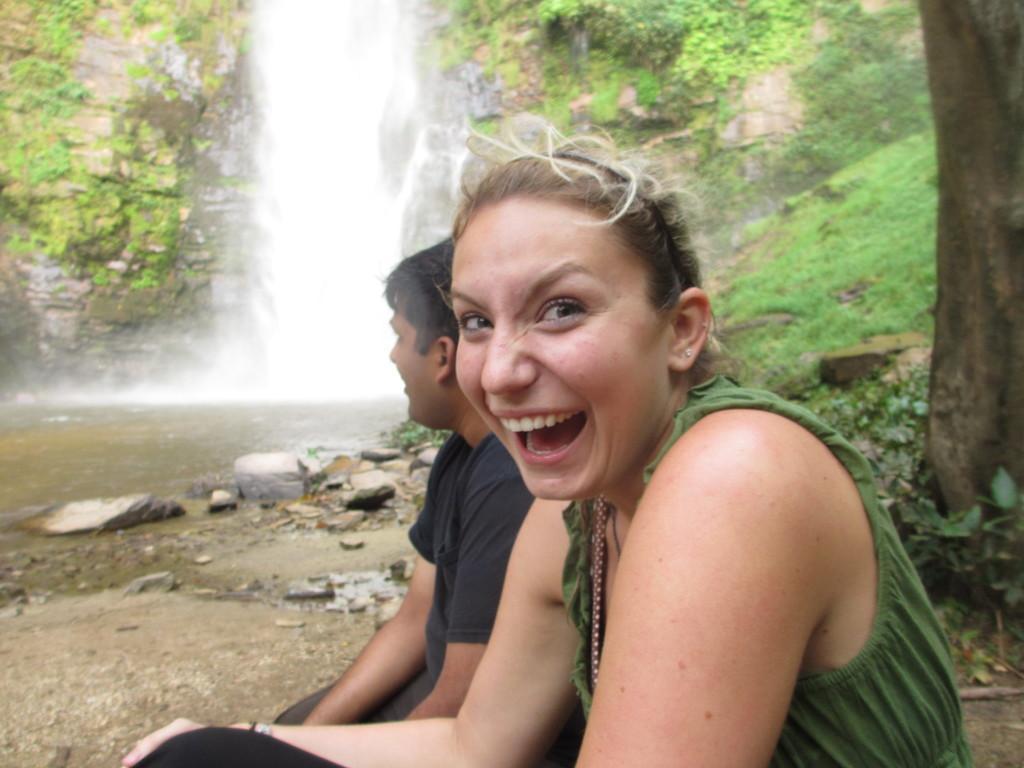Describe this image in one or two sentences. This image consists of a woman wearing green dress is sitting. Beside her there is a man sitting. In the background, there is a waterfall and a mountain. To the left, there is a water flow. At the bottom, there is a ground. 